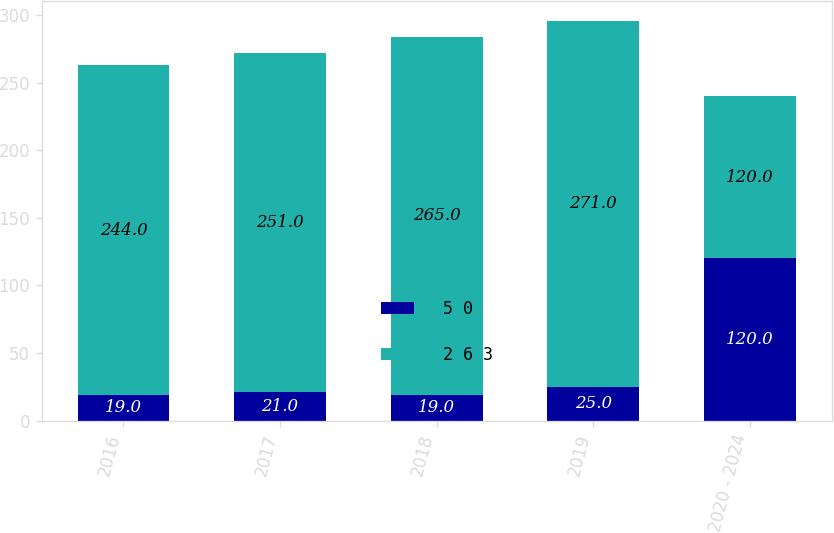Convert chart to OTSL. <chart><loc_0><loc_0><loc_500><loc_500><stacked_bar_chart><ecel><fcel>2016<fcel>2017<fcel>2018<fcel>2019<fcel>2020 - 2024<nl><fcel>5 0<fcel>19<fcel>21<fcel>19<fcel>25<fcel>120<nl><fcel>2 6 3<fcel>244<fcel>251<fcel>265<fcel>271<fcel>120<nl></chart> 